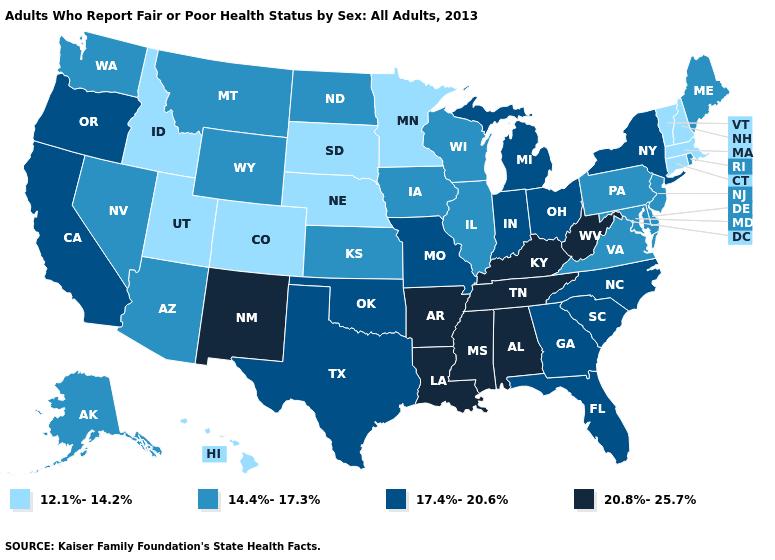What is the highest value in states that border Utah?
Write a very short answer. 20.8%-25.7%. What is the value of Kansas?
Quick response, please. 14.4%-17.3%. What is the lowest value in the South?
Short answer required. 14.4%-17.3%. Does New York have a higher value than Florida?
Give a very brief answer. No. Does California have the lowest value in the West?
Short answer required. No. Does Mississippi have the lowest value in the USA?
Concise answer only. No. Among the states that border Pennsylvania , which have the lowest value?
Quick response, please. Delaware, Maryland, New Jersey. Name the states that have a value in the range 12.1%-14.2%?
Be succinct. Colorado, Connecticut, Hawaii, Idaho, Massachusetts, Minnesota, Nebraska, New Hampshire, South Dakota, Utah, Vermont. Name the states that have a value in the range 12.1%-14.2%?
Keep it brief. Colorado, Connecticut, Hawaii, Idaho, Massachusetts, Minnesota, Nebraska, New Hampshire, South Dakota, Utah, Vermont. Does the map have missing data?
Short answer required. No. Among the states that border Georgia , which have the highest value?
Short answer required. Alabama, Tennessee. Does Wyoming have the same value as Indiana?
Concise answer only. No. Name the states that have a value in the range 17.4%-20.6%?
Answer briefly. California, Florida, Georgia, Indiana, Michigan, Missouri, New York, North Carolina, Ohio, Oklahoma, Oregon, South Carolina, Texas. Which states have the lowest value in the USA?
Be succinct. Colorado, Connecticut, Hawaii, Idaho, Massachusetts, Minnesota, Nebraska, New Hampshire, South Dakota, Utah, Vermont. 